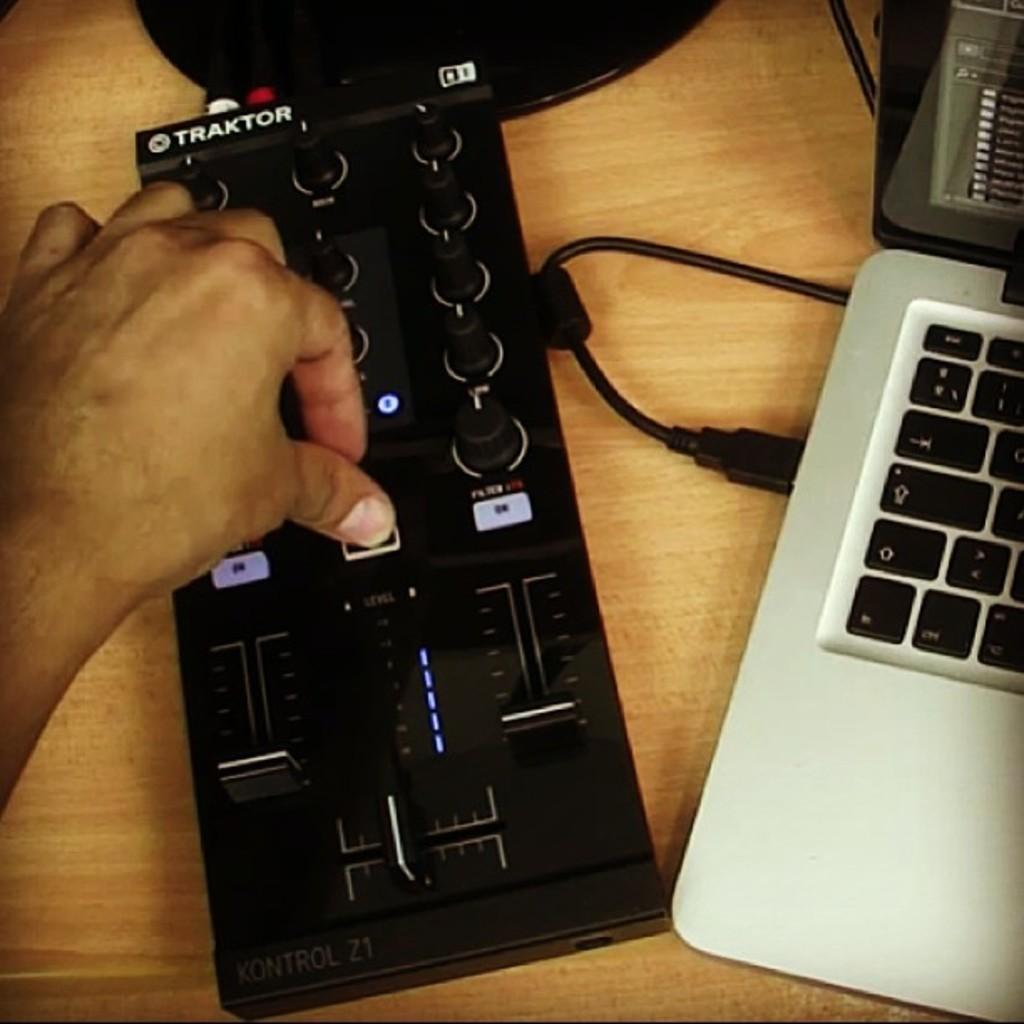<image>
Give a short and clear explanation of the subsequent image. A man pushes a button on a black Traktor electronic device. 